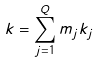Convert formula to latex. <formula><loc_0><loc_0><loc_500><loc_500>k = \sum _ { j = 1 } ^ { Q } m _ { j } k _ { j }</formula> 